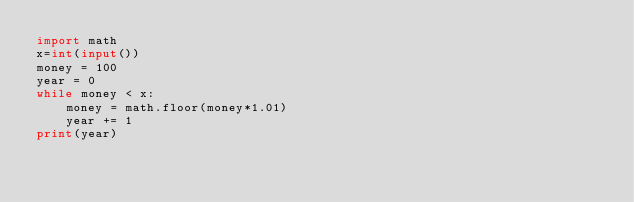Convert code to text. <code><loc_0><loc_0><loc_500><loc_500><_Python_>import math
x=int(input())
money = 100
year = 0
while money < x:
    money = math.floor(money*1.01)
    year += 1
print(year)</code> 